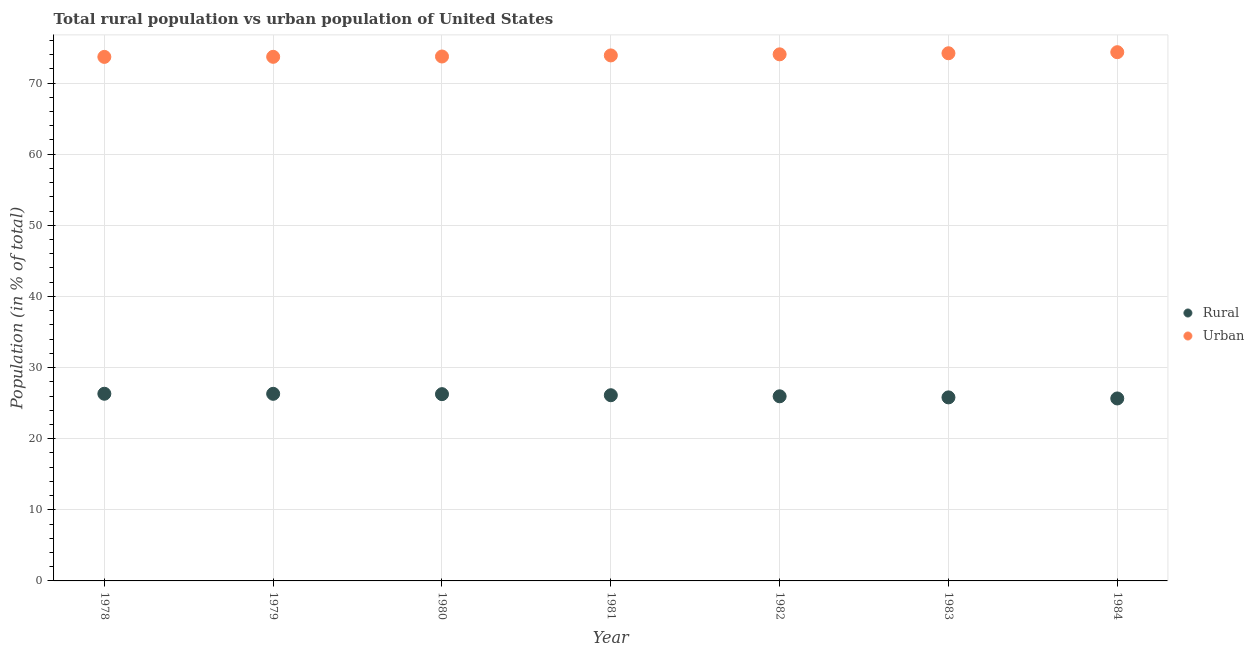What is the rural population in 1980?
Offer a terse response. 26.26. Across all years, what is the maximum urban population?
Your answer should be compact. 74.34. Across all years, what is the minimum rural population?
Your response must be concise. 25.66. What is the total rural population in the graph?
Offer a terse response. 182.42. What is the difference between the rural population in 1978 and that in 1983?
Give a very brief answer. 0.51. What is the difference between the rural population in 1983 and the urban population in 1984?
Provide a succinct answer. -48.54. What is the average urban population per year?
Offer a very short reply. 73.94. In the year 1980, what is the difference between the urban population and rural population?
Offer a very short reply. 47.48. What is the ratio of the rural population in 1978 to that in 1984?
Keep it short and to the point. 1.03. Is the urban population in 1978 less than that in 1982?
Offer a terse response. Yes. Is the difference between the urban population in 1978 and 1984 greater than the difference between the rural population in 1978 and 1984?
Keep it short and to the point. No. What is the difference between the highest and the second highest urban population?
Ensure brevity in your answer.  0.15. What is the difference between the highest and the lowest urban population?
Your answer should be compact. 0.66. In how many years, is the rural population greater than the average rural population taken over all years?
Keep it short and to the point. 4. Is the sum of the urban population in 1981 and 1983 greater than the maximum rural population across all years?
Offer a terse response. Yes. Is the rural population strictly greater than the urban population over the years?
Ensure brevity in your answer.  No. Is the urban population strictly less than the rural population over the years?
Keep it short and to the point. No. How many dotlines are there?
Keep it short and to the point. 2. Are the values on the major ticks of Y-axis written in scientific E-notation?
Your answer should be very brief. No. Does the graph contain grids?
Your response must be concise. Yes. Where does the legend appear in the graph?
Make the answer very short. Center right. How many legend labels are there?
Make the answer very short. 2. What is the title of the graph?
Provide a succinct answer. Total rural population vs urban population of United States. What is the label or title of the X-axis?
Provide a succinct answer. Year. What is the label or title of the Y-axis?
Your answer should be very brief. Population (in % of total). What is the Population (in % of total) in Rural in 1978?
Provide a succinct answer. 26.32. What is the Population (in % of total) of Urban in 1978?
Provide a short and direct response. 73.68. What is the Population (in % of total) in Rural in 1979?
Make the answer very short. 26.31. What is the Population (in % of total) of Urban in 1979?
Give a very brief answer. 73.69. What is the Population (in % of total) of Rural in 1980?
Your response must be concise. 26.26. What is the Population (in % of total) of Urban in 1980?
Offer a terse response. 73.74. What is the Population (in % of total) of Rural in 1981?
Your answer should be very brief. 26.11. What is the Population (in % of total) of Urban in 1981?
Give a very brief answer. 73.89. What is the Population (in % of total) in Rural in 1982?
Ensure brevity in your answer.  25.96. What is the Population (in % of total) in Urban in 1982?
Offer a terse response. 74.04. What is the Population (in % of total) in Rural in 1983?
Provide a succinct answer. 25.81. What is the Population (in % of total) of Urban in 1983?
Offer a terse response. 74.19. What is the Population (in % of total) in Rural in 1984?
Give a very brief answer. 25.66. What is the Population (in % of total) of Urban in 1984?
Make the answer very short. 74.34. Across all years, what is the maximum Population (in % of total) of Rural?
Offer a very short reply. 26.32. Across all years, what is the maximum Population (in % of total) of Urban?
Give a very brief answer. 74.34. Across all years, what is the minimum Population (in % of total) in Rural?
Offer a very short reply. 25.66. Across all years, what is the minimum Population (in % of total) in Urban?
Keep it short and to the point. 73.68. What is the total Population (in % of total) in Rural in the graph?
Give a very brief answer. 182.42. What is the total Population (in % of total) of Urban in the graph?
Provide a short and direct response. 517.58. What is the difference between the Population (in % of total) of Urban in 1978 and that in 1979?
Offer a terse response. -0.01. What is the difference between the Population (in % of total) of Rural in 1978 and that in 1980?
Your answer should be very brief. 0.06. What is the difference between the Population (in % of total) of Urban in 1978 and that in 1980?
Your answer should be very brief. -0.06. What is the difference between the Population (in % of total) of Rural in 1978 and that in 1981?
Provide a short and direct response. 0.21. What is the difference between the Population (in % of total) of Urban in 1978 and that in 1981?
Give a very brief answer. -0.21. What is the difference between the Population (in % of total) of Rural in 1978 and that in 1982?
Provide a short and direct response. 0.36. What is the difference between the Population (in % of total) of Urban in 1978 and that in 1982?
Ensure brevity in your answer.  -0.36. What is the difference between the Population (in % of total) of Rural in 1978 and that in 1983?
Your answer should be very brief. 0.51. What is the difference between the Population (in % of total) in Urban in 1978 and that in 1983?
Provide a succinct answer. -0.51. What is the difference between the Population (in % of total) in Rural in 1978 and that in 1984?
Your answer should be very brief. 0.66. What is the difference between the Population (in % of total) of Urban in 1978 and that in 1984?
Offer a very short reply. -0.66. What is the difference between the Population (in % of total) of Rural in 1979 and that in 1980?
Provide a short and direct response. 0.05. What is the difference between the Population (in % of total) in Urban in 1979 and that in 1980?
Offer a very short reply. -0.05. What is the difference between the Population (in % of total) in Rural in 1979 and that in 1981?
Provide a succinct answer. 0.2. What is the difference between the Population (in % of total) of Urban in 1979 and that in 1981?
Provide a succinct answer. -0.2. What is the difference between the Population (in % of total) of Urban in 1979 and that in 1982?
Offer a very short reply. -0.35. What is the difference between the Population (in % of total) of Rural in 1979 and that in 1983?
Provide a succinct answer. 0.5. What is the difference between the Population (in % of total) in Urban in 1979 and that in 1983?
Provide a short and direct response. -0.5. What is the difference between the Population (in % of total) in Rural in 1979 and that in 1984?
Give a very brief answer. 0.65. What is the difference between the Population (in % of total) in Urban in 1979 and that in 1984?
Provide a short and direct response. -0.65. What is the difference between the Population (in % of total) of Rural in 1980 and that in 1981?
Your answer should be very brief. 0.15. What is the difference between the Population (in % of total) in Urban in 1980 and that in 1981?
Provide a succinct answer. -0.15. What is the difference between the Population (in % of total) in Rural in 1980 and that in 1982?
Keep it short and to the point. 0.3. What is the difference between the Population (in % of total) in Urban in 1980 and that in 1982?
Give a very brief answer. -0.3. What is the difference between the Population (in % of total) of Rural in 1980 and that in 1983?
Offer a terse response. 0.46. What is the difference between the Population (in % of total) in Urban in 1980 and that in 1983?
Offer a terse response. -0.46. What is the difference between the Population (in % of total) in Rural in 1980 and that in 1984?
Offer a terse response. 0.61. What is the difference between the Population (in % of total) in Urban in 1980 and that in 1984?
Your answer should be very brief. -0.61. What is the difference between the Population (in % of total) of Rural in 1981 and that in 1982?
Your response must be concise. 0.15. What is the difference between the Population (in % of total) in Urban in 1981 and that in 1982?
Provide a succinct answer. -0.15. What is the difference between the Population (in % of total) in Rural in 1981 and that in 1983?
Provide a succinct answer. 0.3. What is the difference between the Population (in % of total) of Urban in 1981 and that in 1983?
Offer a terse response. -0.3. What is the difference between the Population (in % of total) of Rural in 1981 and that in 1984?
Your response must be concise. 0.45. What is the difference between the Population (in % of total) in Urban in 1981 and that in 1984?
Your answer should be compact. -0.45. What is the difference between the Population (in % of total) in Rural in 1982 and that in 1983?
Ensure brevity in your answer.  0.15. What is the difference between the Population (in % of total) of Urban in 1982 and that in 1983?
Keep it short and to the point. -0.15. What is the difference between the Population (in % of total) in Rural in 1982 and that in 1984?
Keep it short and to the point. 0.3. What is the difference between the Population (in % of total) of Urban in 1982 and that in 1984?
Make the answer very short. -0.3. What is the difference between the Population (in % of total) of Urban in 1983 and that in 1984?
Make the answer very short. -0.15. What is the difference between the Population (in % of total) in Rural in 1978 and the Population (in % of total) in Urban in 1979?
Your response must be concise. -47.37. What is the difference between the Population (in % of total) of Rural in 1978 and the Population (in % of total) of Urban in 1980?
Your answer should be compact. -47.42. What is the difference between the Population (in % of total) in Rural in 1978 and the Population (in % of total) in Urban in 1981?
Provide a succinct answer. -47.57. What is the difference between the Population (in % of total) of Rural in 1978 and the Population (in % of total) of Urban in 1982?
Provide a short and direct response. -47.72. What is the difference between the Population (in % of total) of Rural in 1978 and the Population (in % of total) of Urban in 1983?
Provide a short and direct response. -47.88. What is the difference between the Population (in % of total) of Rural in 1978 and the Population (in % of total) of Urban in 1984?
Your answer should be compact. -48.03. What is the difference between the Population (in % of total) in Rural in 1979 and the Population (in % of total) in Urban in 1980?
Make the answer very short. -47.43. What is the difference between the Population (in % of total) in Rural in 1979 and the Population (in % of total) in Urban in 1981?
Provide a succinct answer. -47.58. What is the difference between the Population (in % of total) in Rural in 1979 and the Population (in % of total) in Urban in 1982?
Give a very brief answer. -47.73. What is the difference between the Population (in % of total) of Rural in 1979 and the Population (in % of total) of Urban in 1983?
Offer a terse response. -47.89. What is the difference between the Population (in % of total) in Rural in 1979 and the Population (in % of total) in Urban in 1984?
Provide a short and direct response. -48.04. What is the difference between the Population (in % of total) in Rural in 1980 and the Population (in % of total) in Urban in 1981?
Offer a terse response. -47.63. What is the difference between the Population (in % of total) of Rural in 1980 and the Population (in % of total) of Urban in 1982?
Provide a short and direct response. -47.78. What is the difference between the Population (in % of total) in Rural in 1980 and the Population (in % of total) in Urban in 1983?
Your answer should be compact. -47.93. What is the difference between the Population (in % of total) of Rural in 1980 and the Population (in % of total) of Urban in 1984?
Offer a terse response. -48.08. What is the difference between the Population (in % of total) of Rural in 1981 and the Population (in % of total) of Urban in 1982?
Your answer should be compact. -47.93. What is the difference between the Population (in % of total) in Rural in 1981 and the Population (in % of total) in Urban in 1983?
Offer a terse response. -48.08. What is the difference between the Population (in % of total) of Rural in 1981 and the Population (in % of total) of Urban in 1984?
Your response must be concise. -48.23. What is the difference between the Population (in % of total) of Rural in 1982 and the Population (in % of total) of Urban in 1983?
Ensure brevity in your answer.  -48.24. What is the difference between the Population (in % of total) in Rural in 1982 and the Population (in % of total) in Urban in 1984?
Ensure brevity in your answer.  -48.39. What is the difference between the Population (in % of total) in Rural in 1983 and the Population (in % of total) in Urban in 1984?
Ensure brevity in your answer.  -48.54. What is the average Population (in % of total) of Rural per year?
Offer a terse response. 26.06. What is the average Population (in % of total) of Urban per year?
Provide a succinct answer. 73.94. In the year 1978, what is the difference between the Population (in % of total) of Rural and Population (in % of total) of Urban?
Provide a short and direct response. -47.36. In the year 1979, what is the difference between the Population (in % of total) of Rural and Population (in % of total) of Urban?
Offer a terse response. -47.38. In the year 1980, what is the difference between the Population (in % of total) of Rural and Population (in % of total) of Urban?
Your answer should be very brief. -47.48. In the year 1981, what is the difference between the Population (in % of total) in Rural and Population (in % of total) in Urban?
Keep it short and to the point. -47.78. In the year 1982, what is the difference between the Population (in % of total) in Rural and Population (in % of total) in Urban?
Offer a very short reply. -48.08. In the year 1983, what is the difference between the Population (in % of total) in Rural and Population (in % of total) in Urban?
Provide a succinct answer. -48.39. In the year 1984, what is the difference between the Population (in % of total) of Rural and Population (in % of total) of Urban?
Make the answer very short. -48.69. What is the ratio of the Population (in % of total) in Rural in 1978 to that in 1979?
Provide a succinct answer. 1. What is the ratio of the Population (in % of total) of Urban in 1978 to that in 1980?
Ensure brevity in your answer.  1. What is the ratio of the Population (in % of total) in Rural in 1978 to that in 1981?
Make the answer very short. 1.01. What is the ratio of the Population (in % of total) of Rural in 1978 to that in 1982?
Keep it short and to the point. 1.01. What is the ratio of the Population (in % of total) in Urban in 1978 to that in 1982?
Provide a short and direct response. 1. What is the ratio of the Population (in % of total) in Rural in 1978 to that in 1983?
Offer a very short reply. 1.02. What is the ratio of the Population (in % of total) in Urban in 1978 to that in 1983?
Give a very brief answer. 0.99. What is the ratio of the Population (in % of total) in Rural in 1978 to that in 1984?
Offer a very short reply. 1.03. What is the ratio of the Population (in % of total) of Rural in 1979 to that in 1980?
Offer a terse response. 1. What is the ratio of the Population (in % of total) in Urban in 1979 to that in 1980?
Provide a succinct answer. 1. What is the ratio of the Population (in % of total) in Rural in 1979 to that in 1981?
Your answer should be compact. 1.01. What is the ratio of the Population (in % of total) in Rural in 1979 to that in 1982?
Make the answer very short. 1.01. What is the ratio of the Population (in % of total) in Rural in 1979 to that in 1983?
Give a very brief answer. 1.02. What is the ratio of the Population (in % of total) in Urban in 1979 to that in 1983?
Give a very brief answer. 0.99. What is the ratio of the Population (in % of total) in Rural in 1979 to that in 1984?
Offer a very short reply. 1.03. What is the ratio of the Population (in % of total) of Rural in 1980 to that in 1981?
Give a very brief answer. 1.01. What is the ratio of the Population (in % of total) in Rural in 1980 to that in 1982?
Provide a succinct answer. 1.01. What is the ratio of the Population (in % of total) in Urban in 1980 to that in 1982?
Make the answer very short. 1. What is the ratio of the Population (in % of total) in Rural in 1980 to that in 1983?
Provide a short and direct response. 1.02. What is the ratio of the Population (in % of total) of Urban in 1980 to that in 1983?
Provide a succinct answer. 0.99. What is the ratio of the Population (in % of total) of Rural in 1980 to that in 1984?
Provide a succinct answer. 1.02. What is the ratio of the Population (in % of total) of Urban in 1980 to that in 1984?
Provide a short and direct response. 0.99. What is the ratio of the Population (in % of total) in Rural in 1981 to that in 1982?
Your answer should be very brief. 1.01. What is the ratio of the Population (in % of total) in Rural in 1981 to that in 1983?
Your answer should be very brief. 1.01. What is the ratio of the Population (in % of total) of Rural in 1981 to that in 1984?
Provide a short and direct response. 1.02. What is the ratio of the Population (in % of total) in Rural in 1982 to that in 1983?
Offer a terse response. 1.01. What is the ratio of the Population (in % of total) in Urban in 1982 to that in 1983?
Give a very brief answer. 1. What is the ratio of the Population (in % of total) of Rural in 1982 to that in 1984?
Keep it short and to the point. 1.01. What is the ratio of the Population (in % of total) of Urban in 1983 to that in 1984?
Keep it short and to the point. 1. What is the difference between the highest and the second highest Population (in % of total) of Urban?
Give a very brief answer. 0.15. What is the difference between the highest and the lowest Population (in % of total) of Rural?
Your answer should be very brief. 0.66. What is the difference between the highest and the lowest Population (in % of total) of Urban?
Provide a short and direct response. 0.66. 